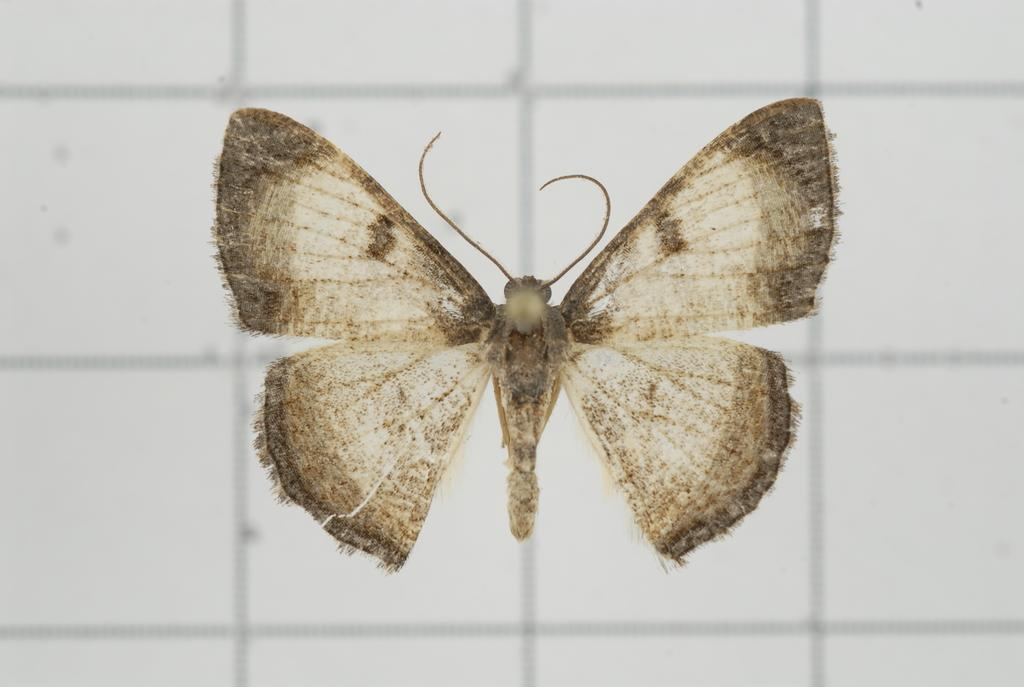What is depicted on the floor in the image? There is a butterfly represented on the floor in the image. What type of toothbrush is being used in the war depicted in the image? There is no war or toothbrush present in the image; it features a butterfly on the floor. 